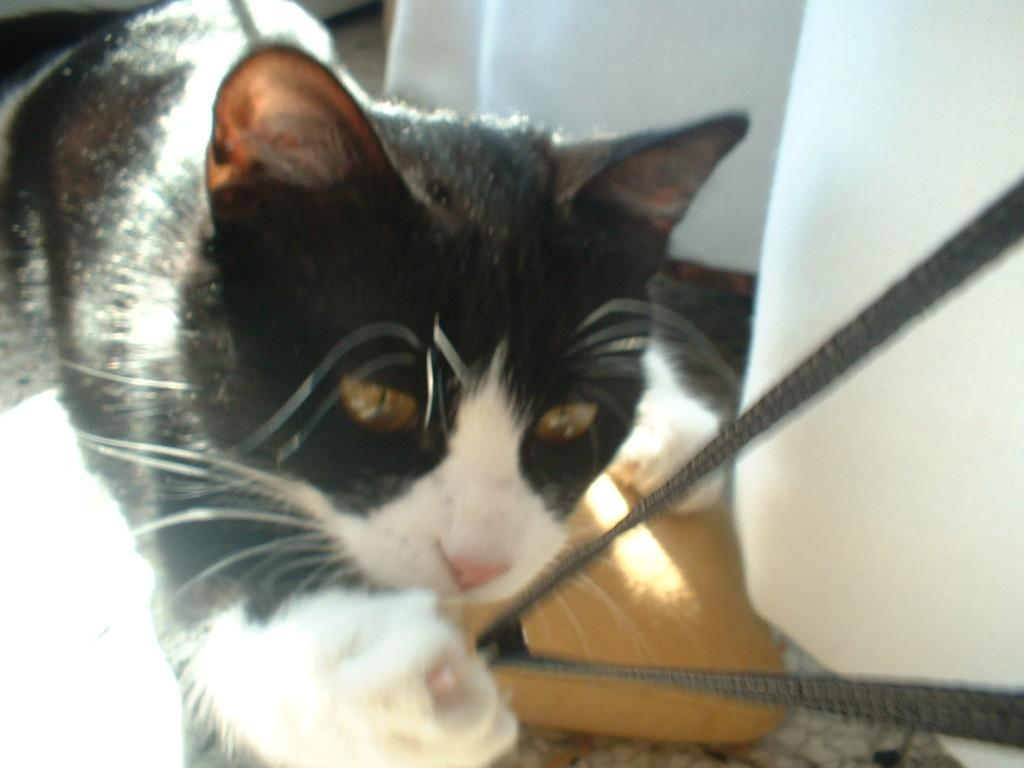What type of animal is in the image? There is a cat in the image. Can you describe the coloring of the cat? The cat has white and black coloring. What is the color of the object in the image? The object in the image has brown and ash coloring. What type of window treatment is present in the image? There is a white color curtain in the image. What type of tomatoes are being taught to the family in the image? There are no tomatoes or family present in the image; it features a cat with white and black coloring, a brown and ash color object, and a white color curtain. 